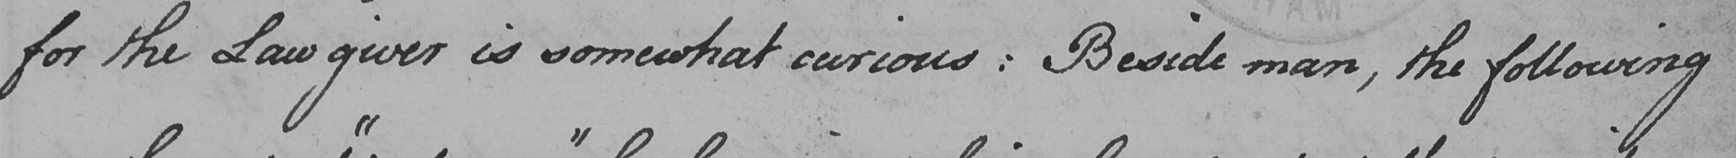Transcribe the text shown in this historical manuscript line. for the Law giver is somewhat curious :  Beside man , the following 